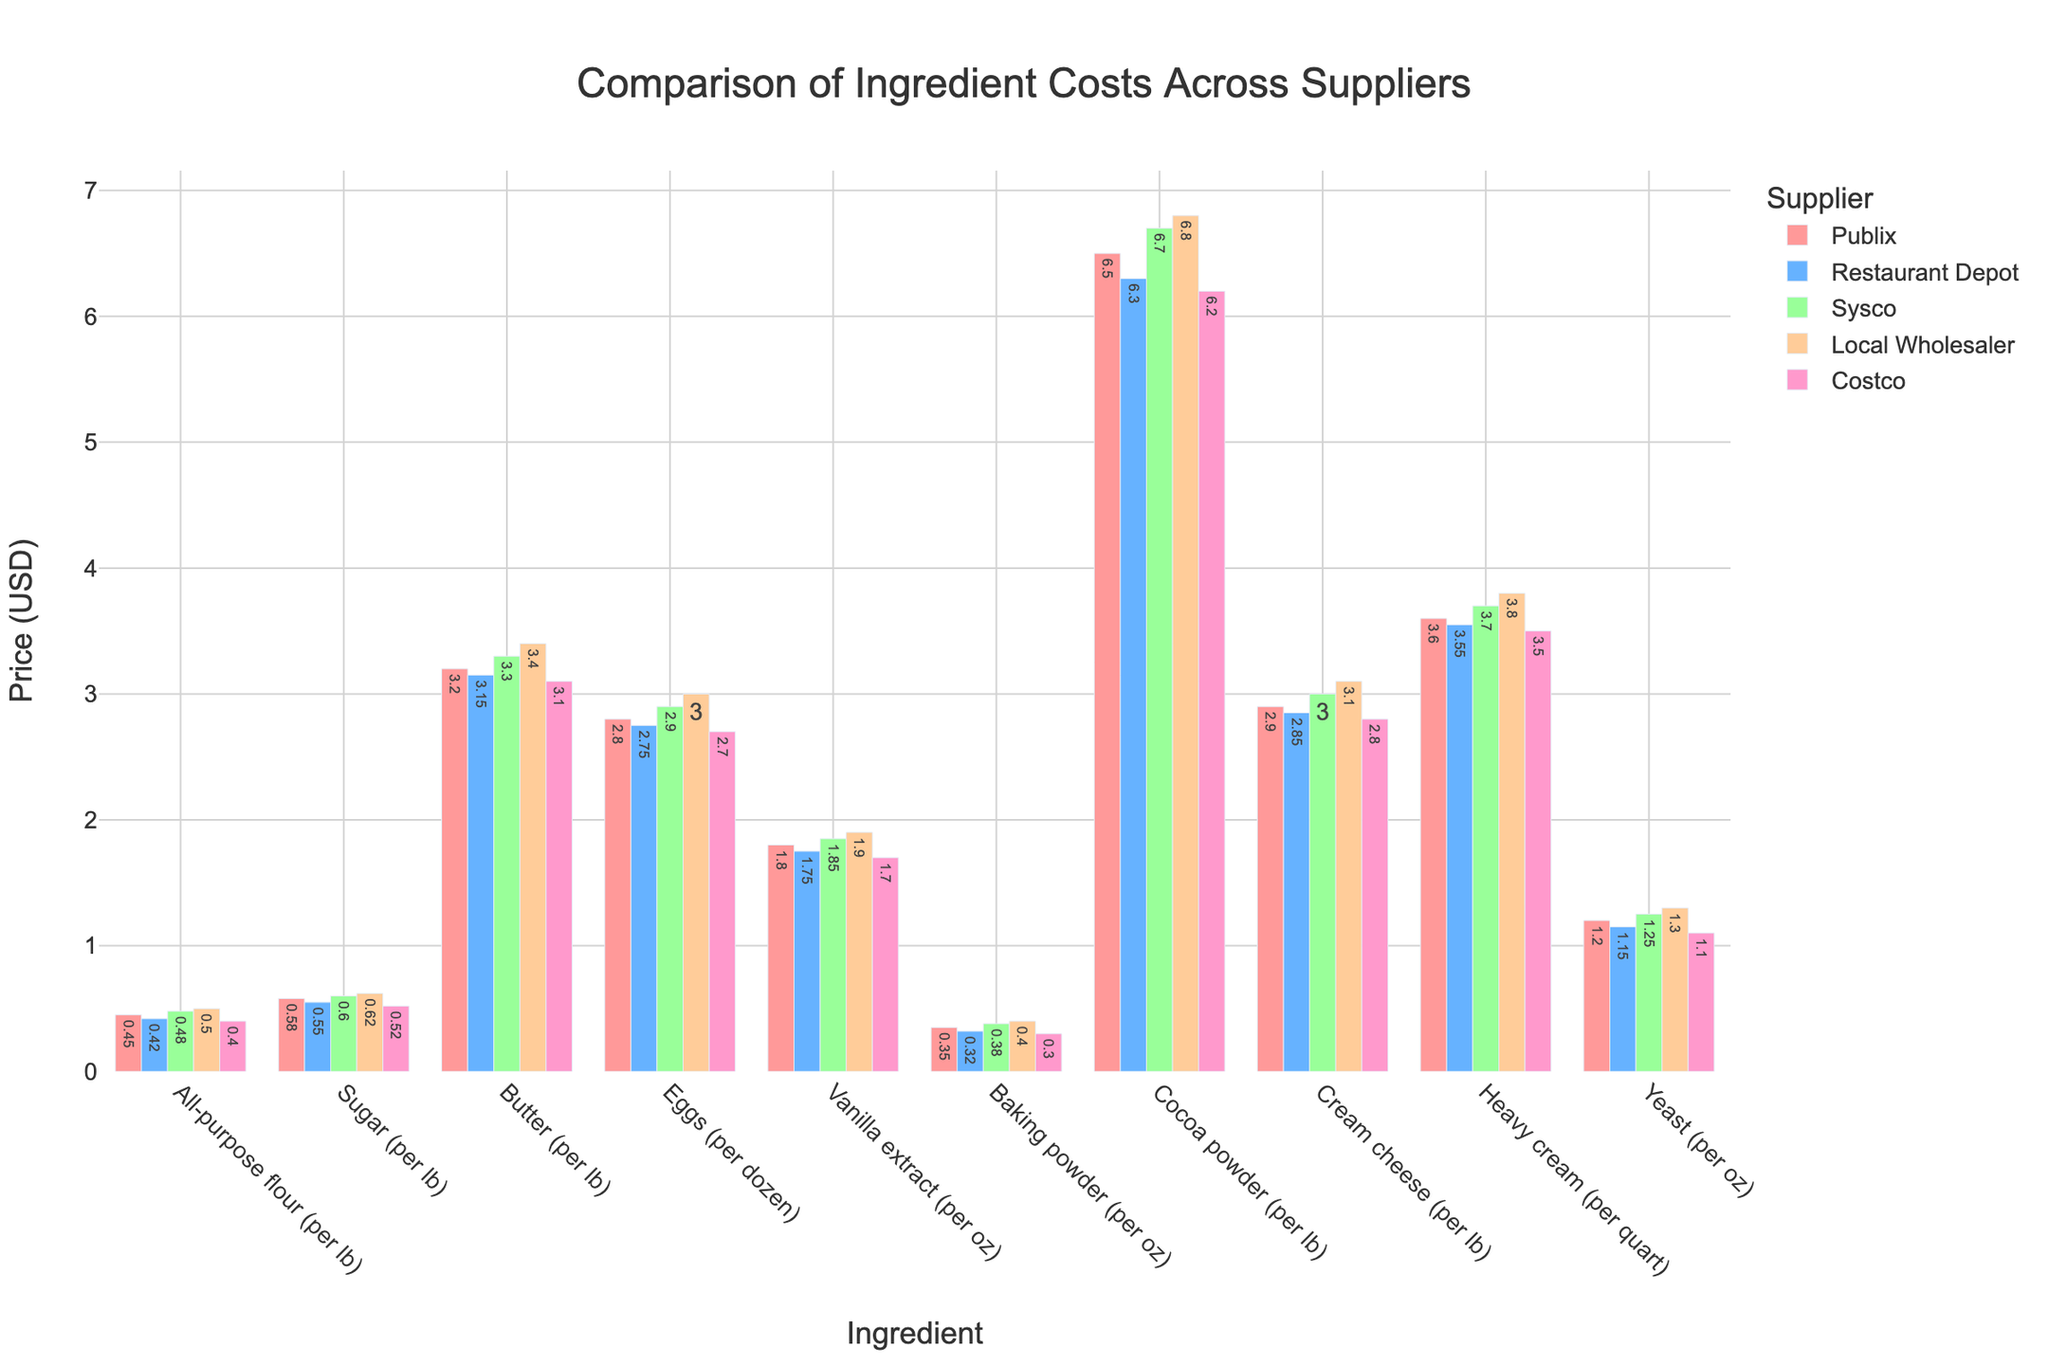Which supplier offers the cheapest all-purpose flour? Look at the bar heights for all-purpose flour across all suppliers and identify the shortest bar. Costco has the shortest bar for all-purpose flour.
Answer: Costco Which ingredient costs the most at Publix? Compare the lengths of all the bars corresponding to Publix across all ingredients. The longest bar for Publix is cocoa powder at $6.50 per pound.
Answer: Cocoa powder What is the price difference of butter between Publix and Costco? Subtract the cost of butter from Costco from the cost of butter from Publix ($3.20 - $3.10). The difference is $0.10.
Answer: $0.10 Which supplier has the highest average cost for the ingredients listed? Calculate the average cost for each supplier across all ingredients by summing the costs and dividing by the number of ingredients. Comparing these averages, Local Wholesaler has the highest average.
Answer: Local Wholesaler For which ingredient does Costco offer the lowest price compared to all other suppliers? Compare the bar heights for Costco with the other suppliers for each ingredient and find the ingredients where Costco has the lowest bar. Costco offers the lowest price for yeast, baking powder, heavy cream, cocoa powder, vanilla extract, and all-purpose flour.
Answer: Yeast, Baking powder, Heavy cream, Cocoa powder, Vanilla extract, All-purpose flour Rank the suppliers from cheapest to most expensive for eggs. Compare the bar heights for eggs for each supplier. The ranking is: Costco ($2.70), Restaurant Depot ($2.75), Publix ($2.80), Sysco ($2.90), Local Wholesaler ($3.00).
Answer: Costco, Restaurant Depot, Publix, Sysco, Local Wholesaler Which ingredient shows the least variation in cost among the suppliers? Identify the ingredient with the smallest range between its highest and lowest prices by comparing the difference for each ingredient. Baking powder has the smallest range from $0.30 to $0.40, a difference of $0.10.
Answer: Baking powder How much more expensive is cream cheese from Local Wholesaler compared to Restaurant Depot? Subtract the cost of cream cheese from Restaurant Depot from the cost from Local Wholesaler ($3.10 - $2.85). The difference is $0.25.
Answer: $0.25 What is the average cost of sugar across all suppliers? Sum the cost of sugar from all suppliers and divide by the number of suppliers ((0.58 + 0.55 + 0.60 + 0.62 + 0.52) / 5). The average cost is $0.57.
Answer: $0.57 